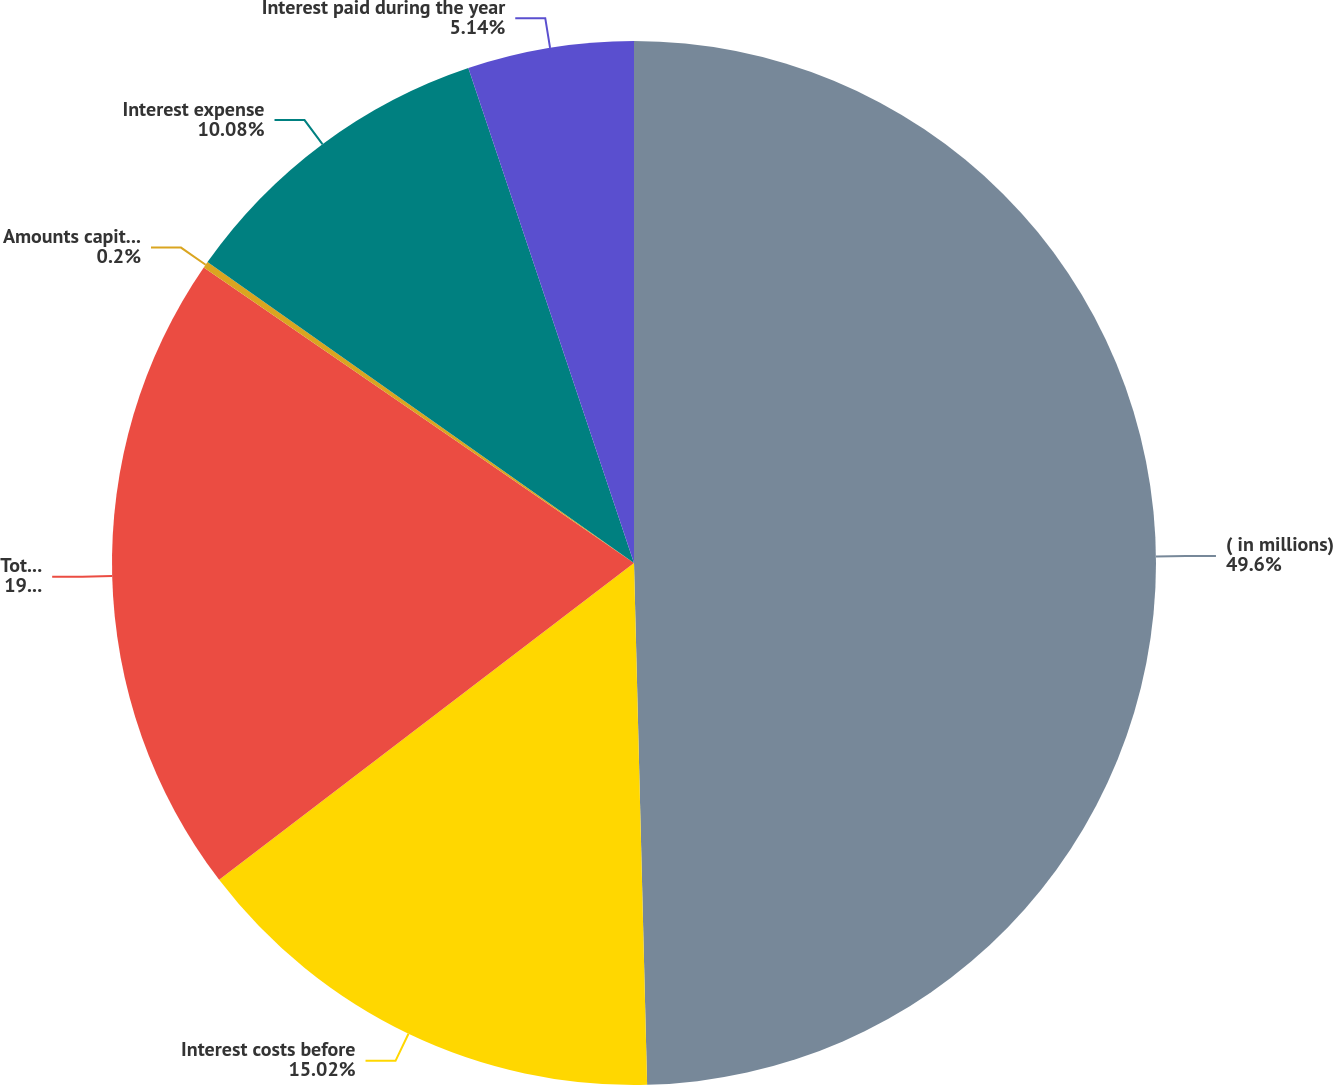<chart> <loc_0><loc_0><loc_500><loc_500><pie_chart><fcel>( in millions)<fcel>Interest costs before<fcel>Total interest costs<fcel>Amounts capitalized<fcel>Interest expense<fcel>Interest paid during the year<nl><fcel>49.6%<fcel>15.02%<fcel>19.96%<fcel>0.2%<fcel>10.08%<fcel>5.14%<nl></chart> 